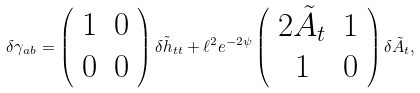<formula> <loc_0><loc_0><loc_500><loc_500>\delta \gamma _ { a b } = \left ( \begin{array} { c c } 1 & 0 \\ 0 & 0 \\ \end{array} \right ) \delta \tilde { h } _ { t t } + \ell ^ { 2 } e ^ { - 2 \psi } \left ( \begin{array} { c c } 2 \tilde { A } _ { t } & 1 \\ 1 & 0 \\ \end{array} \right ) \delta \tilde { A } _ { t } ,</formula> 